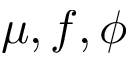<formula> <loc_0><loc_0><loc_500><loc_500>\mu , f , \phi</formula> 